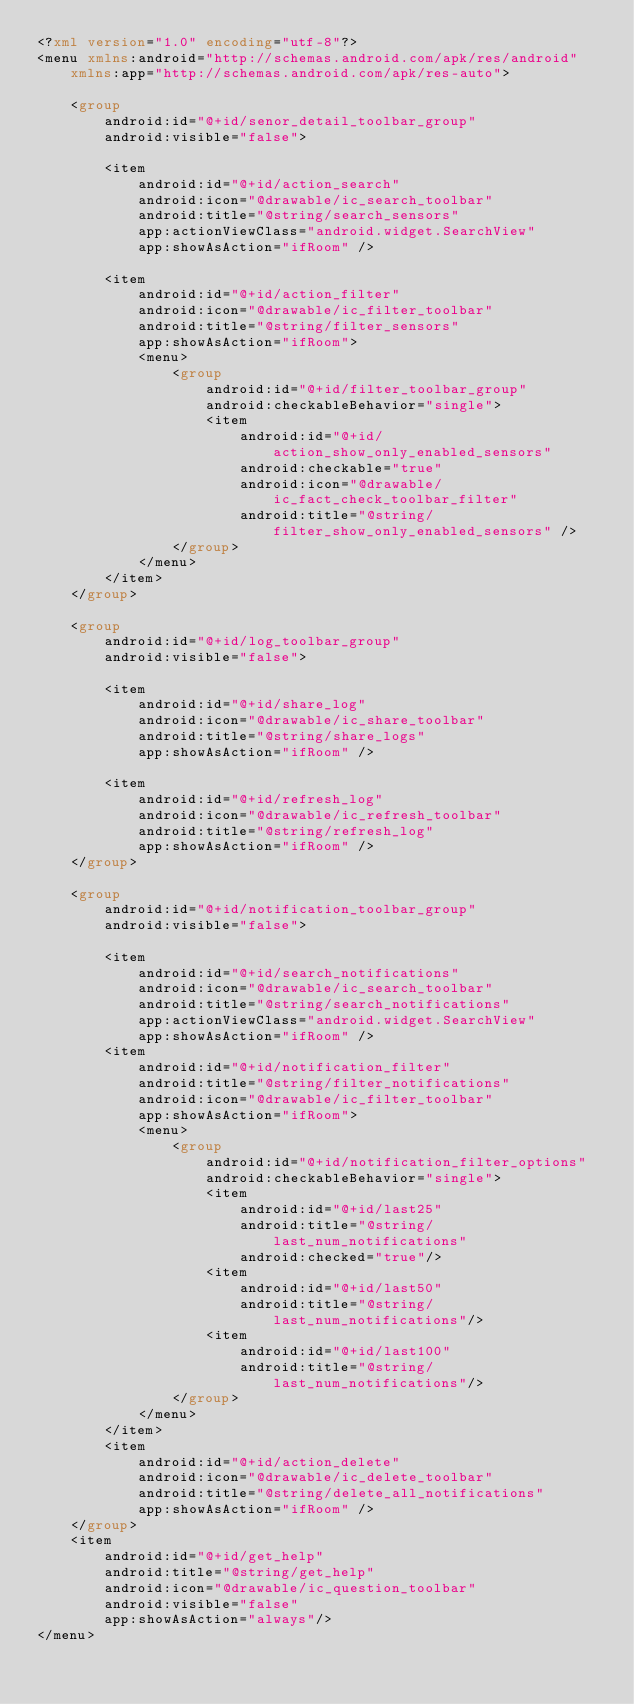<code> <loc_0><loc_0><loc_500><loc_500><_XML_><?xml version="1.0" encoding="utf-8"?>
<menu xmlns:android="http://schemas.android.com/apk/res/android"
    xmlns:app="http://schemas.android.com/apk/res-auto">

    <group
        android:id="@+id/senor_detail_toolbar_group"
        android:visible="false">

        <item
            android:id="@+id/action_search"
            android:icon="@drawable/ic_search_toolbar"
            android:title="@string/search_sensors"
            app:actionViewClass="android.widget.SearchView"
            app:showAsAction="ifRoom" />

        <item
            android:id="@+id/action_filter"
            android:icon="@drawable/ic_filter_toolbar"
            android:title="@string/filter_sensors"
            app:showAsAction="ifRoom">
            <menu>
                <group
                    android:id="@+id/filter_toolbar_group"
                    android:checkableBehavior="single">
                    <item
                        android:id="@+id/action_show_only_enabled_sensors"
                        android:checkable="true"
                        android:icon="@drawable/ic_fact_check_toolbar_filter"
                        android:title="@string/filter_show_only_enabled_sensors" />
                </group>
            </menu>
        </item>
    </group>

    <group
        android:id="@+id/log_toolbar_group"
        android:visible="false">

        <item
            android:id="@+id/share_log"
            android:icon="@drawable/ic_share_toolbar"
            android:title="@string/share_logs"
            app:showAsAction="ifRoom" />

        <item
            android:id="@+id/refresh_log"
            android:icon="@drawable/ic_refresh_toolbar"
            android:title="@string/refresh_log"
            app:showAsAction="ifRoom" />
    </group>

    <group
        android:id="@+id/notification_toolbar_group"
        android:visible="false">

        <item
            android:id="@+id/search_notifications"
            android:icon="@drawable/ic_search_toolbar"
            android:title="@string/search_notifications"
            app:actionViewClass="android.widget.SearchView"
            app:showAsAction="ifRoom" />
        <item
            android:id="@+id/notification_filter"
            android:title="@string/filter_notifications"
            android:icon="@drawable/ic_filter_toolbar"
            app:showAsAction="ifRoom">
            <menu>
                <group
                    android:id="@+id/notification_filter_options"
                    android:checkableBehavior="single">
                    <item
                        android:id="@+id/last25"
                        android:title="@string/last_num_notifications"
                        android:checked="true"/>
                    <item
                        android:id="@+id/last50"
                        android:title="@string/last_num_notifications"/>
                    <item
                        android:id="@+id/last100"
                        android:title="@string/last_num_notifications"/>
                </group>
            </menu>
        </item>
        <item
            android:id="@+id/action_delete"
            android:icon="@drawable/ic_delete_toolbar"
            android:title="@string/delete_all_notifications"
            app:showAsAction="ifRoom" />
    </group>
    <item
        android:id="@+id/get_help"
        android:title="@string/get_help"
        android:icon="@drawable/ic_question_toolbar"
        android:visible="false"
        app:showAsAction="always"/>
</menu></code> 